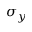<formula> <loc_0><loc_0><loc_500><loc_500>\sigma _ { y }</formula> 